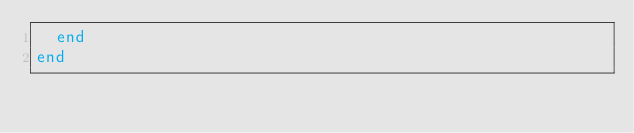Convert code to text. <code><loc_0><loc_0><loc_500><loc_500><_Elixir_>  end
end
</code> 